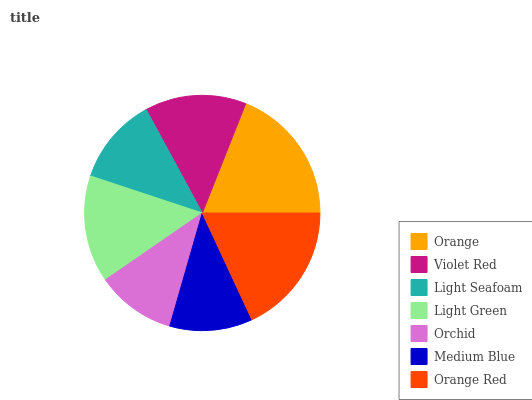Is Orchid the minimum?
Answer yes or no. Yes. Is Orange the maximum?
Answer yes or no. Yes. Is Violet Red the minimum?
Answer yes or no. No. Is Violet Red the maximum?
Answer yes or no. No. Is Orange greater than Violet Red?
Answer yes or no. Yes. Is Violet Red less than Orange?
Answer yes or no. Yes. Is Violet Red greater than Orange?
Answer yes or no. No. Is Orange less than Violet Red?
Answer yes or no. No. Is Violet Red the high median?
Answer yes or no. Yes. Is Violet Red the low median?
Answer yes or no. Yes. Is Orange the high median?
Answer yes or no. No. Is Orchid the low median?
Answer yes or no. No. 